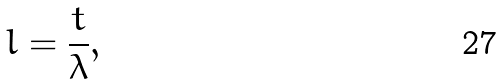Convert formula to latex. <formula><loc_0><loc_0><loc_500><loc_500>l = \frac { t } { \lambda } ,</formula> 